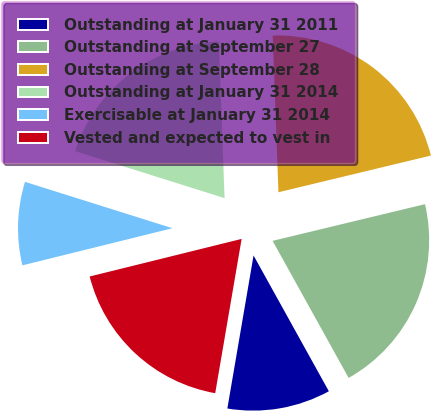<chart> <loc_0><loc_0><loc_500><loc_500><pie_chart><fcel>Outstanding at January 31 2011<fcel>Outstanding at September 27<fcel>Outstanding at September 28<fcel>Outstanding at January 31 2014<fcel>Exercisable at January 31 2014<fcel>Vested and expected to vest in<nl><fcel>10.76%<fcel>20.7%<fcel>21.82%<fcel>19.57%<fcel>8.71%<fcel>18.44%<nl></chart> 